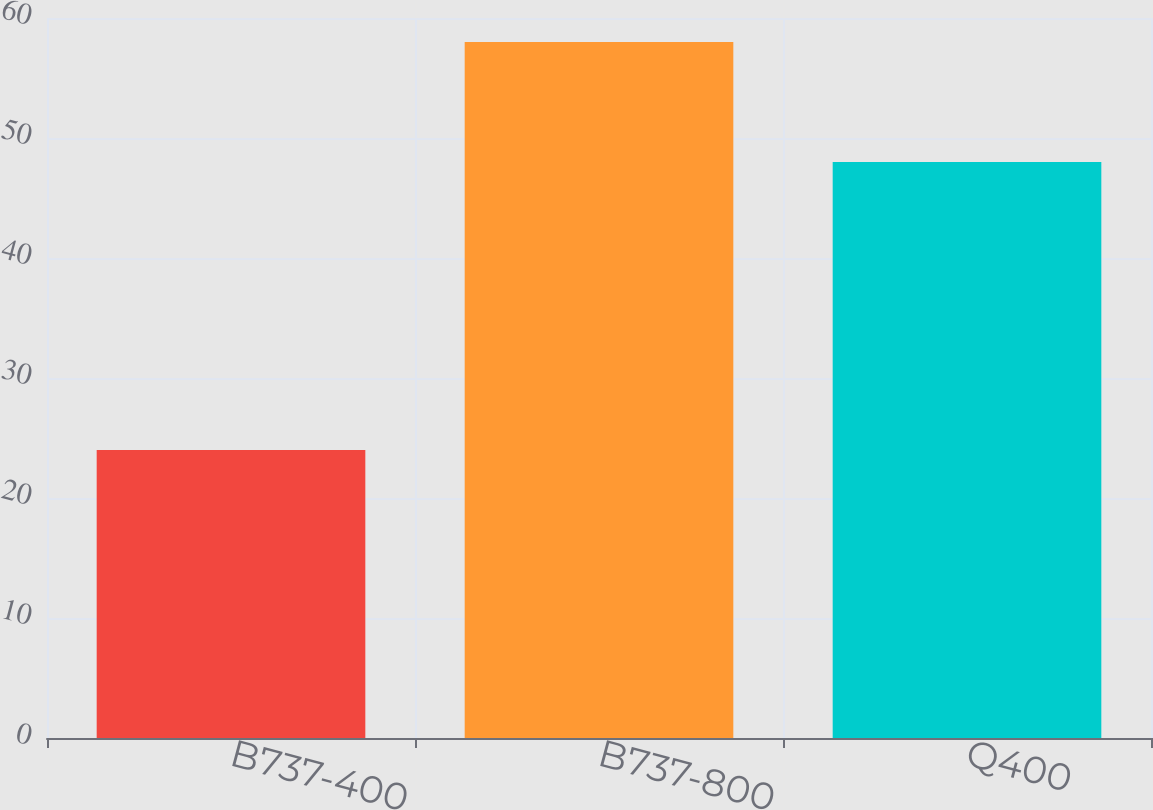Convert chart. <chart><loc_0><loc_0><loc_500><loc_500><bar_chart><fcel>B737-400<fcel>B737-800<fcel>Q400<nl><fcel>24<fcel>58<fcel>48<nl></chart> 